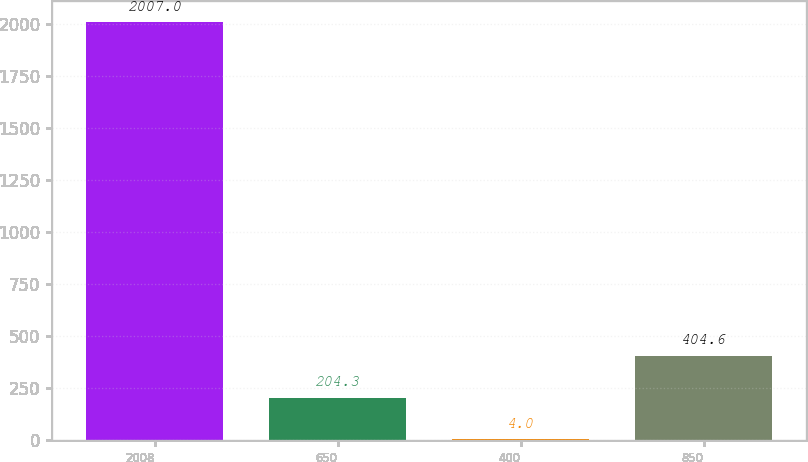<chart> <loc_0><loc_0><loc_500><loc_500><bar_chart><fcel>2008<fcel>650<fcel>400<fcel>850<nl><fcel>2007<fcel>204.3<fcel>4<fcel>404.6<nl></chart> 